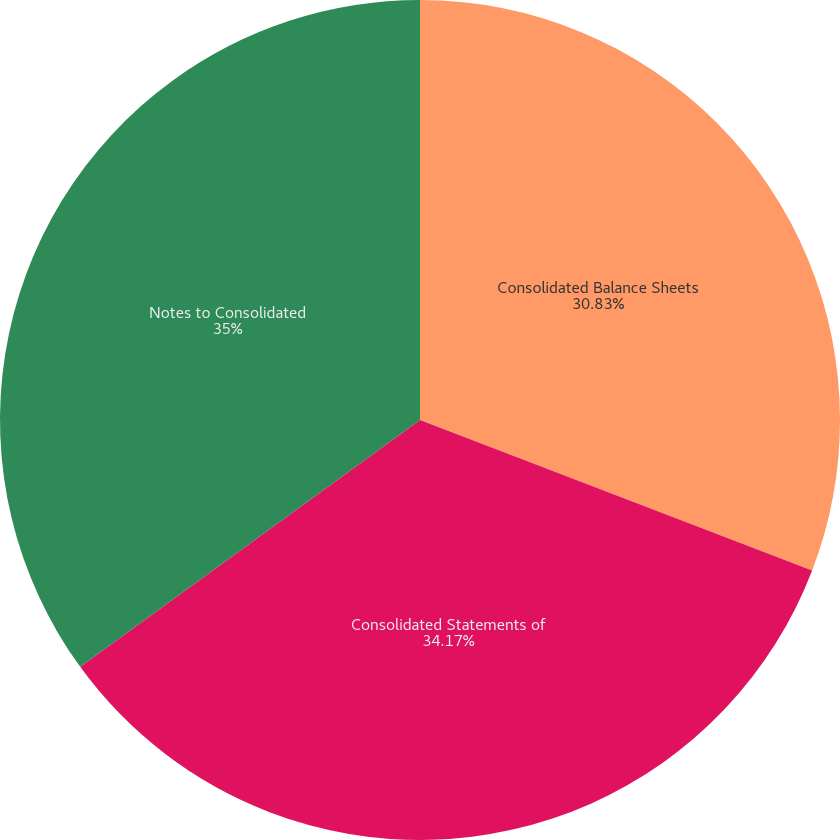<chart> <loc_0><loc_0><loc_500><loc_500><pie_chart><fcel>Consolidated Balance Sheets<fcel>Consolidated Statements of<fcel>Notes to Consolidated<nl><fcel>30.83%<fcel>34.17%<fcel>35.0%<nl></chart> 